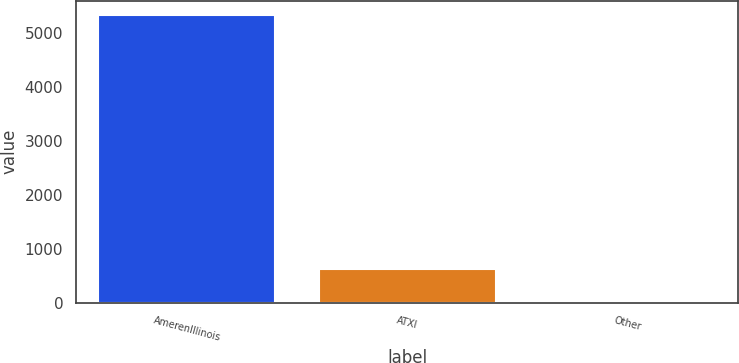<chart> <loc_0><loc_0><loc_500><loc_500><bar_chart><fcel>AmerenIllinois<fcel>ATXI<fcel>Other<nl><fcel>5325<fcel>625<fcel>15<nl></chart> 